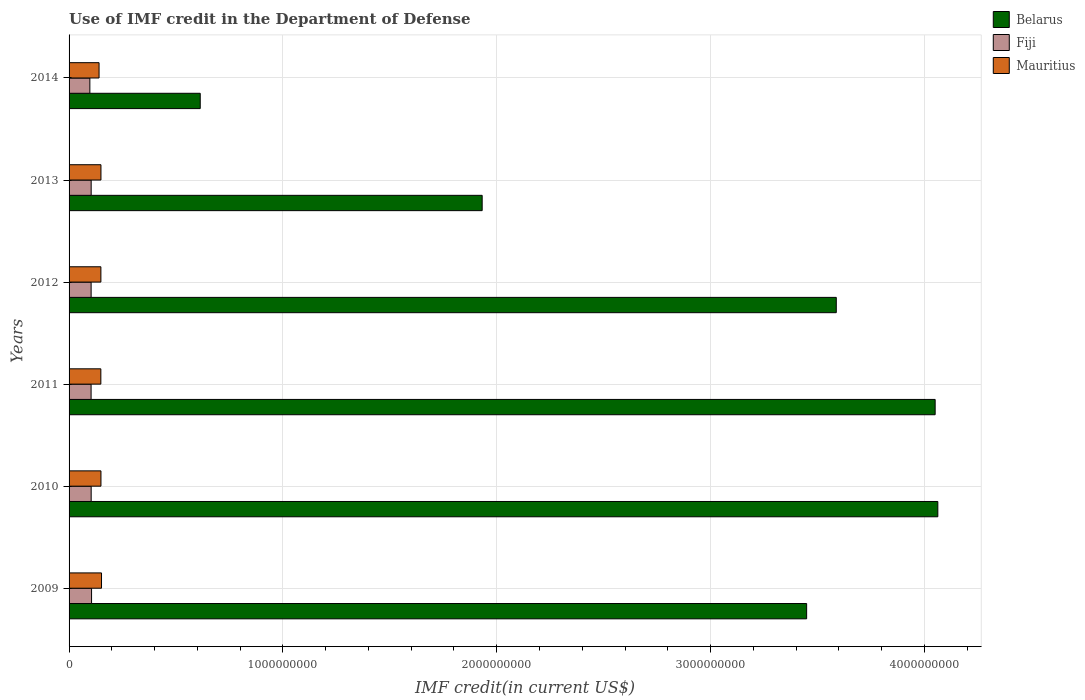How many different coloured bars are there?
Keep it short and to the point. 3. Are the number of bars per tick equal to the number of legend labels?
Your answer should be compact. Yes. How many bars are there on the 1st tick from the top?
Offer a terse response. 3. How many bars are there on the 5th tick from the bottom?
Provide a short and direct response. 3. What is the label of the 3rd group of bars from the top?
Offer a very short reply. 2012. What is the IMF credit in the Department of Defense in Fiji in 2013?
Your answer should be very brief. 1.03e+08. Across all years, what is the maximum IMF credit in the Department of Defense in Fiji?
Offer a terse response. 1.05e+08. Across all years, what is the minimum IMF credit in the Department of Defense in Belarus?
Make the answer very short. 6.13e+08. In which year was the IMF credit in the Department of Defense in Mauritius minimum?
Offer a terse response. 2014. What is the total IMF credit in the Department of Defense in Fiji in the graph?
Make the answer very short. 6.15e+08. What is the difference between the IMF credit in the Department of Defense in Fiji in 2011 and that in 2012?
Ensure brevity in your answer.  -1.11e+05. What is the difference between the IMF credit in the Department of Defense in Mauritius in 2009 and the IMF credit in the Department of Defense in Fiji in 2012?
Your answer should be very brief. 4.86e+07. What is the average IMF credit in the Department of Defense in Belarus per year?
Ensure brevity in your answer.  2.95e+09. In the year 2011, what is the difference between the IMF credit in the Department of Defense in Mauritius and IMF credit in the Department of Defense in Fiji?
Offer a very short reply. 4.56e+07. What is the ratio of the IMF credit in the Department of Defense in Fiji in 2011 to that in 2013?
Keep it short and to the point. 1. Is the difference between the IMF credit in the Department of Defense in Mauritius in 2012 and 2014 greater than the difference between the IMF credit in the Department of Defense in Fiji in 2012 and 2014?
Provide a short and direct response. Yes. What is the difference between the highest and the second highest IMF credit in the Department of Defense in Mauritius?
Offer a very short reply. 2.68e+06. What is the difference between the highest and the lowest IMF credit in the Department of Defense in Belarus?
Provide a succinct answer. 3.45e+09. In how many years, is the IMF credit in the Department of Defense in Fiji greater than the average IMF credit in the Department of Defense in Fiji taken over all years?
Keep it short and to the point. 5. Is the sum of the IMF credit in the Department of Defense in Mauritius in 2009 and 2010 greater than the maximum IMF credit in the Department of Defense in Belarus across all years?
Provide a short and direct response. No. What does the 2nd bar from the top in 2012 represents?
Provide a succinct answer. Fiji. What does the 3rd bar from the bottom in 2012 represents?
Make the answer very short. Mauritius. How many bars are there?
Provide a short and direct response. 18. Are all the bars in the graph horizontal?
Keep it short and to the point. Yes. How many years are there in the graph?
Provide a short and direct response. 6. Where does the legend appear in the graph?
Give a very brief answer. Top right. How many legend labels are there?
Your answer should be compact. 3. How are the legend labels stacked?
Provide a short and direct response. Vertical. What is the title of the graph?
Provide a succinct answer. Use of IMF credit in the Department of Defense. What is the label or title of the X-axis?
Your response must be concise. IMF credit(in current US$). What is the label or title of the Y-axis?
Make the answer very short. Years. What is the IMF credit(in current US$) of Belarus in 2009?
Provide a succinct answer. 3.45e+09. What is the IMF credit(in current US$) of Fiji in 2009?
Offer a terse response. 1.05e+08. What is the IMF credit(in current US$) in Mauritius in 2009?
Keep it short and to the point. 1.52e+08. What is the IMF credit(in current US$) in Belarus in 2010?
Your response must be concise. 4.06e+09. What is the IMF credit(in current US$) of Fiji in 2010?
Your answer should be very brief. 1.03e+08. What is the IMF credit(in current US$) of Mauritius in 2010?
Offer a very short reply. 1.49e+08. What is the IMF credit(in current US$) in Belarus in 2011?
Offer a very short reply. 4.05e+09. What is the IMF credit(in current US$) of Fiji in 2011?
Offer a very short reply. 1.03e+08. What is the IMF credit(in current US$) in Mauritius in 2011?
Your answer should be very brief. 1.49e+08. What is the IMF credit(in current US$) in Belarus in 2012?
Provide a succinct answer. 3.59e+09. What is the IMF credit(in current US$) of Fiji in 2012?
Offer a very short reply. 1.03e+08. What is the IMF credit(in current US$) of Mauritius in 2012?
Your answer should be compact. 1.49e+08. What is the IMF credit(in current US$) of Belarus in 2013?
Keep it short and to the point. 1.93e+09. What is the IMF credit(in current US$) of Fiji in 2013?
Your answer should be compact. 1.03e+08. What is the IMF credit(in current US$) in Mauritius in 2013?
Ensure brevity in your answer.  1.49e+08. What is the IMF credit(in current US$) in Belarus in 2014?
Make the answer very short. 6.13e+08. What is the IMF credit(in current US$) of Fiji in 2014?
Offer a terse response. 9.72e+07. What is the IMF credit(in current US$) of Mauritius in 2014?
Offer a very short reply. 1.40e+08. Across all years, what is the maximum IMF credit(in current US$) in Belarus?
Offer a very short reply. 4.06e+09. Across all years, what is the maximum IMF credit(in current US$) in Fiji?
Provide a short and direct response. 1.05e+08. Across all years, what is the maximum IMF credit(in current US$) of Mauritius?
Offer a terse response. 1.52e+08. Across all years, what is the minimum IMF credit(in current US$) of Belarus?
Offer a terse response. 6.13e+08. Across all years, what is the minimum IMF credit(in current US$) in Fiji?
Ensure brevity in your answer.  9.72e+07. Across all years, what is the minimum IMF credit(in current US$) in Mauritius?
Make the answer very short. 1.40e+08. What is the total IMF credit(in current US$) in Belarus in the graph?
Keep it short and to the point. 1.77e+1. What is the total IMF credit(in current US$) in Fiji in the graph?
Provide a succinct answer. 6.15e+08. What is the total IMF credit(in current US$) of Mauritius in the graph?
Keep it short and to the point. 8.88e+08. What is the difference between the IMF credit(in current US$) in Belarus in 2009 and that in 2010?
Your answer should be compact. -6.14e+08. What is the difference between the IMF credit(in current US$) in Fiji in 2009 and that in 2010?
Give a very brief answer. 1.86e+06. What is the difference between the IMF credit(in current US$) of Mauritius in 2009 and that in 2010?
Provide a succinct answer. 2.68e+06. What is the difference between the IMF credit(in current US$) in Belarus in 2009 and that in 2011?
Provide a succinct answer. -6.01e+08. What is the difference between the IMF credit(in current US$) in Fiji in 2009 and that in 2011?
Make the answer very short. 2.18e+06. What is the difference between the IMF credit(in current US$) of Mauritius in 2009 and that in 2011?
Provide a succinct answer. 3.14e+06. What is the difference between the IMF credit(in current US$) in Belarus in 2009 and that in 2012?
Provide a short and direct response. -1.39e+08. What is the difference between the IMF credit(in current US$) of Fiji in 2009 and that in 2012?
Provide a succinct answer. 2.06e+06. What is the difference between the IMF credit(in current US$) in Mauritius in 2009 and that in 2012?
Provide a short and direct response. 2.98e+06. What is the difference between the IMF credit(in current US$) in Belarus in 2009 and that in 2013?
Provide a succinct answer. 1.52e+09. What is the difference between the IMF credit(in current US$) of Fiji in 2009 and that in 2013?
Provide a short and direct response. 1.86e+06. What is the difference between the IMF credit(in current US$) in Mauritius in 2009 and that in 2013?
Make the answer very short. 2.68e+06. What is the difference between the IMF credit(in current US$) in Belarus in 2009 and that in 2014?
Provide a short and direct response. 2.84e+09. What is the difference between the IMF credit(in current US$) of Fiji in 2009 and that in 2014?
Your answer should be compact. 7.98e+06. What is the difference between the IMF credit(in current US$) of Mauritius in 2009 and that in 2014?
Ensure brevity in your answer.  1.15e+07. What is the difference between the IMF credit(in current US$) in Belarus in 2010 and that in 2011?
Provide a short and direct response. 1.26e+07. What is the difference between the IMF credit(in current US$) of Fiji in 2010 and that in 2011?
Your response must be concise. 3.19e+05. What is the difference between the IMF credit(in current US$) of Mauritius in 2010 and that in 2011?
Your answer should be very brief. 4.60e+05. What is the difference between the IMF credit(in current US$) of Belarus in 2010 and that in 2012?
Make the answer very short. 4.75e+08. What is the difference between the IMF credit(in current US$) in Fiji in 2010 and that in 2012?
Your response must be concise. 2.08e+05. What is the difference between the IMF credit(in current US$) of Mauritius in 2010 and that in 2012?
Keep it short and to the point. 3.01e+05. What is the difference between the IMF credit(in current US$) in Belarus in 2010 and that in 2013?
Provide a short and direct response. 2.13e+09. What is the difference between the IMF credit(in current US$) of Belarus in 2010 and that in 2014?
Your answer should be very brief. 3.45e+09. What is the difference between the IMF credit(in current US$) in Fiji in 2010 and that in 2014?
Provide a succinct answer. 6.12e+06. What is the difference between the IMF credit(in current US$) in Mauritius in 2010 and that in 2014?
Provide a short and direct response. 8.83e+06. What is the difference between the IMF credit(in current US$) in Belarus in 2011 and that in 2012?
Your answer should be compact. 4.62e+08. What is the difference between the IMF credit(in current US$) of Fiji in 2011 and that in 2012?
Give a very brief answer. -1.11e+05. What is the difference between the IMF credit(in current US$) of Mauritius in 2011 and that in 2012?
Provide a short and direct response. -1.59e+05. What is the difference between the IMF credit(in current US$) in Belarus in 2011 and that in 2013?
Give a very brief answer. 2.12e+09. What is the difference between the IMF credit(in current US$) in Fiji in 2011 and that in 2013?
Your response must be concise. -3.17e+05. What is the difference between the IMF credit(in current US$) of Mauritius in 2011 and that in 2013?
Your response must be concise. -4.58e+05. What is the difference between the IMF credit(in current US$) in Belarus in 2011 and that in 2014?
Provide a succinct answer. 3.44e+09. What is the difference between the IMF credit(in current US$) of Fiji in 2011 and that in 2014?
Your response must be concise. 5.80e+06. What is the difference between the IMF credit(in current US$) in Mauritius in 2011 and that in 2014?
Keep it short and to the point. 8.37e+06. What is the difference between the IMF credit(in current US$) in Belarus in 2012 and that in 2013?
Your response must be concise. 1.66e+09. What is the difference between the IMF credit(in current US$) of Fiji in 2012 and that in 2013?
Your answer should be compact. -2.06e+05. What is the difference between the IMF credit(in current US$) of Mauritius in 2012 and that in 2013?
Provide a succinct answer. -2.99e+05. What is the difference between the IMF credit(in current US$) of Belarus in 2012 and that in 2014?
Your answer should be very brief. 2.97e+09. What is the difference between the IMF credit(in current US$) in Fiji in 2012 and that in 2014?
Your answer should be very brief. 5.91e+06. What is the difference between the IMF credit(in current US$) of Mauritius in 2012 and that in 2014?
Give a very brief answer. 8.53e+06. What is the difference between the IMF credit(in current US$) of Belarus in 2013 and that in 2014?
Your answer should be compact. 1.32e+09. What is the difference between the IMF credit(in current US$) of Fiji in 2013 and that in 2014?
Give a very brief answer. 6.12e+06. What is the difference between the IMF credit(in current US$) of Mauritius in 2013 and that in 2014?
Your answer should be compact. 8.83e+06. What is the difference between the IMF credit(in current US$) of Belarus in 2009 and the IMF credit(in current US$) of Fiji in 2010?
Provide a succinct answer. 3.35e+09. What is the difference between the IMF credit(in current US$) of Belarus in 2009 and the IMF credit(in current US$) of Mauritius in 2010?
Give a very brief answer. 3.30e+09. What is the difference between the IMF credit(in current US$) in Fiji in 2009 and the IMF credit(in current US$) in Mauritius in 2010?
Offer a terse response. -4.39e+07. What is the difference between the IMF credit(in current US$) in Belarus in 2009 and the IMF credit(in current US$) in Fiji in 2011?
Your answer should be very brief. 3.35e+09. What is the difference between the IMF credit(in current US$) in Belarus in 2009 and the IMF credit(in current US$) in Mauritius in 2011?
Your answer should be very brief. 3.30e+09. What is the difference between the IMF credit(in current US$) in Fiji in 2009 and the IMF credit(in current US$) in Mauritius in 2011?
Your response must be concise. -4.34e+07. What is the difference between the IMF credit(in current US$) in Belarus in 2009 and the IMF credit(in current US$) in Fiji in 2012?
Provide a succinct answer. 3.35e+09. What is the difference between the IMF credit(in current US$) in Belarus in 2009 and the IMF credit(in current US$) in Mauritius in 2012?
Ensure brevity in your answer.  3.30e+09. What is the difference between the IMF credit(in current US$) of Fiji in 2009 and the IMF credit(in current US$) of Mauritius in 2012?
Provide a succinct answer. -4.36e+07. What is the difference between the IMF credit(in current US$) of Belarus in 2009 and the IMF credit(in current US$) of Fiji in 2013?
Your response must be concise. 3.35e+09. What is the difference between the IMF credit(in current US$) in Belarus in 2009 and the IMF credit(in current US$) in Mauritius in 2013?
Offer a terse response. 3.30e+09. What is the difference between the IMF credit(in current US$) of Fiji in 2009 and the IMF credit(in current US$) of Mauritius in 2013?
Keep it short and to the point. -4.39e+07. What is the difference between the IMF credit(in current US$) of Belarus in 2009 and the IMF credit(in current US$) of Fiji in 2014?
Offer a very short reply. 3.35e+09. What is the difference between the IMF credit(in current US$) of Belarus in 2009 and the IMF credit(in current US$) of Mauritius in 2014?
Ensure brevity in your answer.  3.31e+09. What is the difference between the IMF credit(in current US$) in Fiji in 2009 and the IMF credit(in current US$) in Mauritius in 2014?
Ensure brevity in your answer.  -3.51e+07. What is the difference between the IMF credit(in current US$) in Belarus in 2010 and the IMF credit(in current US$) in Fiji in 2011?
Give a very brief answer. 3.96e+09. What is the difference between the IMF credit(in current US$) of Belarus in 2010 and the IMF credit(in current US$) of Mauritius in 2011?
Keep it short and to the point. 3.91e+09. What is the difference between the IMF credit(in current US$) of Fiji in 2010 and the IMF credit(in current US$) of Mauritius in 2011?
Your answer should be compact. -4.53e+07. What is the difference between the IMF credit(in current US$) in Belarus in 2010 and the IMF credit(in current US$) in Fiji in 2012?
Provide a succinct answer. 3.96e+09. What is the difference between the IMF credit(in current US$) in Belarus in 2010 and the IMF credit(in current US$) in Mauritius in 2012?
Your response must be concise. 3.91e+09. What is the difference between the IMF credit(in current US$) of Fiji in 2010 and the IMF credit(in current US$) of Mauritius in 2012?
Provide a succinct answer. -4.55e+07. What is the difference between the IMF credit(in current US$) in Belarus in 2010 and the IMF credit(in current US$) in Fiji in 2013?
Provide a succinct answer. 3.96e+09. What is the difference between the IMF credit(in current US$) of Belarus in 2010 and the IMF credit(in current US$) of Mauritius in 2013?
Ensure brevity in your answer.  3.91e+09. What is the difference between the IMF credit(in current US$) in Fiji in 2010 and the IMF credit(in current US$) in Mauritius in 2013?
Provide a short and direct response. -4.58e+07. What is the difference between the IMF credit(in current US$) of Belarus in 2010 and the IMF credit(in current US$) of Fiji in 2014?
Your answer should be compact. 3.97e+09. What is the difference between the IMF credit(in current US$) in Belarus in 2010 and the IMF credit(in current US$) in Mauritius in 2014?
Keep it short and to the point. 3.92e+09. What is the difference between the IMF credit(in current US$) in Fiji in 2010 and the IMF credit(in current US$) in Mauritius in 2014?
Offer a very short reply. -3.69e+07. What is the difference between the IMF credit(in current US$) in Belarus in 2011 and the IMF credit(in current US$) in Fiji in 2012?
Your answer should be very brief. 3.95e+09. What is the difference between the IMF credit(in current US$) in Belarus in 2011 and the IMF credit(in current US$) in Mauritius in 2012?
Make the answer very short. 3.90e+09. What is the difference between the IMF credit(in current US$) in Fiji in 2011 and the IMF credit(in current US$) in Mauritius in 2012?
Make the answer very short. -4.58e+07. What is the difference between the IMF credit(in current US$) of Belarus in 2011 and the IMF credit(in current US$) of Fiji in 2013?
Offer a terse response. 3.95e+09. What is the difference between the IMF credit(in current US$) in Belarus in 2011 and the IMF credit(in current US$) in Mauritius in 2013?
Offer a very short reply. 3.90e+09. What is the difference between the IMF credit(in current US$) of Fiji in 2011 and the IMF credit(in current US$) of Mauritius in 2013?
Your answer should be very brief. -4.61e+07. What is the difference between the IMF credit(in current US$) of Belarus in 2011 and the IMF credit(in current US$) of Fiji in 2014?
Provide a succinct answer. 3.95e+09. What is the difference between the IMF credit(in current US$) in Belarus in 2011 and the IMF credit(in current US$) in Mauritius in 2014?
Keep it short and to the point. 3.91e+09. What is the difference between the IMF credit(in current US$) of Fiji in 2011 and the IMF credit(in current US$) of Mauritius in 2014?
Offer a very short reply. -3.72e+07. What is the difference between the IMF credit(in current US$) in Belarus in 2012 and the IMF credit(in current US$) in Fiji in 2013?
Make the answer very short. 3.48e+09. What is the difference between the IMF credit(in current US$) of Belarus in 2012 and the IMF credit(in current US$) of Mauritius in 2013?
Give a very brief answer. 3.44e+09. What is the difference between the IMF credit(in current US$) in Fiji in 2012 and the IMF credit(in current US$) in Mauritius in 2013?
Your answer should be very brief. -4.60e+07. What is the difference between the IMF credit(in current US$) in Belarus in 2012 and the IMF credit(in current US$) in Fiji in 2014?
Your response must be concise. 3.49e+09. What is the difference between the IMF credit(in current US$) of Belarus in 2012 and the IMF credit(in current US$) of Mauritius in 2014?
Your answer should be very brief. 3.45e+09. What is the difference between the IMF credit(in current US$) of Fiji in 2012 and the IMF credit(in current US$) of Mauritius in 2014?
Keep it short and to the point. -3.71e+07. What is the difference between the IMF credit(in current US$) in Belarus in 2013 and the IMF credit(in current US$) in Fiji in 2014?
Keep it short and to the point. 1.83e+09. What is the difference between the IMF credit(in current US$) in Belarus in 2013 and the IMF credit(in current US$) in Mauritius in 2014?
Provide a short and direct response. 1.79e+09. What is the difference between the IMF credit(in current US$) of Fiji in 2013 and the IMF credit(in current US$) of Mauritius in 2014?
Your response must be concise. -3.69e+07. What is the average IMF credit(in current US$) of Belarus per year?
Provide a succinct answer. 2.95e+09. What is the average IMF credit(in current US$) in Fiji per year?
Your answer should be compact. 1.03e+08. What is the average IMF credit(in current US$) of Mauritius per year?
Provide a succinct answer. 1.48e+08. In the year 2009, what is the difference between the IMF credit(in current US$) of Belarus and IMF credit(in current US$) of Fiji?
Provide a short and direct response. 3.34e+09. In the year 2009, what is the difference between the IMF credit(in current US$) of Belarus and IMF credit(in current US$) of Mauritius?
Offer a terse response. 3.30e+09. In the year 2009, what is the difference between the IMF credit(in current US$) of Fiji and IMF credit(in current US$) of Mauritius?
Provide a short and direct response. -4.66e+07. In the year 2010, what is the difference between the IMF credit(in current US$) in Belarus and IMF credit(in current US$) in Fiji?
Your response must be concise. 3.96e+09. In the year 2010, what is the difference between the IMF credit(in current US$) in Belarus and IMF credit(in current US$) in Mauritius?
Give a very brief answer. 3.91e+09. In the year 2010, what is the difference between the IMF credit(in current US$) in Fiji and IMF credit(in current US$) in Mauritius?
Your response must be concise. -4.58e+07. In the year 2011, what is the difference between the IMF credit(in current US$) of Belarus and IMF credit(in current US$) of Fiji?
Your response must be concise. 3.95e+09. In the year 2011, what is the difference between the IMF credit(in current US$) in Belarus and IMF credit(in current US$) in Mauritius?
Give a very brief answer. 3.90e+09. In the year 2011, what is the difference between the IMF credit(in current US$) in Fiji and IMF credit(in current US$) in Mauritius?
Ensure brevity in your answer.  -4.56e+07. In the year 2012, what is the difference between the IMF credit(in current US$) in Belarus and IMF credit(in current US$) in Fiji?
Provide a short and direct response. 3.48e+09. In the year 2012, what is the difference between the IMF credit(in current US$) in Belarus and IMF credit(in current US$) in Mauritius?
Offer a terse response. 3.44e+09. In the year 2012, what is the difference between the IMF credit(in current US$) in Fiji and IMF credit(in current US$) in Mauritius?
Give a very brief answer. -4.57e+07. In the year 2013, what is the difference between the IMF credit(in current US$) in Belarus and IMF credit(in current US$) in Fiji?
Offer a very short reply. 1.83e+09. In the year 2013, what is the difference between the IMF credit(in current US$) of Belarus and IMF credit(in current US$) of Mauritius?
Your answer should be compact. 1.78e+09. In the year 2013, what is the difference between the IMF credit(in current US$) of Fiji and IMF credit(in current US$) of Mauritius?
Provide a short and direct response. -4.58e+07. In the year 2014, what is the difference between the IMF credit(in current US$) of Belarus and IMF credit(in current US$) of Fiji?
Give a very brief answer. 5.16e+08. In the year 2014, what is the difference between the IMF credit(in current US$) in Belarus and IMF credit(in current US$) in Mauritius?
Provide a succinct answer. 4.73e+08. In the year 2014, what is the difference between the IMF credit(in current US$) of Fiji and IMF credit(in current US$) of Mauritius?
Your response must be concise. -4.30e+07. What is the ratio of the IMF credit(in current US$) in Belarus in 2009 to that in 2010?
Your response must be concise. 0.85. What is the ratio of the IMF credit(in current US$) in Fiji in 2009 to that in 2010?
Your answer should be very brief. 1.02. What is the ratio of the IMF credit(in current US$) of Mauritius in 2009 to that in 2010?
Ensure brevity in your answer.  1.02. What is the ratio of the IMF credit(in current US$) of Belarus in 2009 to that in 2011?
Make the answer very short. 0.85. What is the ratio of the IMF credit(in current US$) in Fiji in 2009 to that in 2011?
Your response must be concise. 1.02. What is the ratio of the IMF credit(in current US$) of Mauritius in 2009 to that in 2011?
Offer a terse response. 1.02. What is the ratio of the IMF credit(in current US$) in Belarus in 2009 to that in 2012?
Your answer should be compact. 0.96. What is the ratio of the IMF credit(in current US$) of Mauritius in 2009 to that in 2012?
Offer a terse response. 1.02. What is the ratio of the IMF credit(in current US$) of Belarus in 2009 to that in 2013?
Make the answer very short. 1.79. What is the ratio of the IMF credit(in current US$) in Belarus in 2009 to that in 2014?
Give a very brief answer. 5.62. What is the ratio of the IMF credit(in current US$) of Fiji in 2009 to that in 2014?
Offer a terse response. 1.08. What is the ratio of the IMF credit(in current US$) of Mauritius in 2009 to that in 2014?
Provide a succinct answer. 1.08. What is the ratio of the IMF credit(in current US$) of Belarus in 2010 to that in 2012?
Make the answer very short. 1.13. What is the ratio of the IMF credit(in current US$) in Fiji in 2010 to that in 2012?
Provide a short and direct response. 1. What is the ratio of the IMF credit(in current US$) in Belarus in 2010 to that in 2013?
Your answer should be very brief. 2.1. What is the ratio of the IMF credit(in current US$) in Belarus in 2010 to that in 2014?
Your answer should be very brief. 6.62. What is the ratio of the IMF credit(in current US$) in Fiji in 2010 to that in 2014?
Your response must be concise. 1.06. What is the ratio of the IMF credit(in current US$) in Mauritius in 2010 to that in 2014?
Your answer should be compact. 1.06. What is the ratio of the IMF credit(in current US$) in Belarus in 2011 to that in 2012?
Offer a terse response. 1.13. What is the ratio of the IMF credit(in current US$) of Belarus in 2011 to that in 2013?
Give a very brief answer. 2.1. What is the ratio of the IMF credit(in current US$) of Belarus in 2011 to that in 2014?
Keep it short and to the point. 6.6. What is the ratio of the IMF credit(in current US$) in Fiji in 2011 to that in 2014?
Provide a short and direct response. 1.06. What is the ratio of the IMF credit(in current US$) of Mauritius in 2011 to that in 2014?
Offer a terse response. 1.06. What is the ratio of the IMF credit(in current US$) in Belarus in 2012 to that in 2013?
Provide a succinct answer. 1.86. What is the ratio of the IMF credit(in current US$) in Belarus in 2012 to that in 2014?
Provide a succinct answer. 5.85. What is the ratio of the IMF credit(in current US$) of Fiji in 2012 to that in 2014?
Provide a short and direct response. 1.06. What is the ratio of the IMF credit(in current US$) in Mauritius in 2012 to that in 2014?
Your response must be concise. 1.06. What is the ratio of the IMF credit(in current US$) in Belarus in 2013 to that in 2014?
Ensure brevity in your answer.  3.15. What is the ratio of the IMF credit(in current US$) of Fiji in 2013 to that in 2014?
Provide a short and direct response. 1.06. What is the ratio of the IMF credit(in current US$) of Mauritius in 2013 to that in 2014?
Provide a succinct answer. 1.06. What is the difference between the highest and the second highest IMF credit(in current US$) in Belarus?
Make the answer very short. 1.26e+07. What is the difference between the highest and the second highest IMF credit(in current US$) of Fiji?
Offer a very short reply. 1.86e+06. What is the difference between the highest and the second highest IMF credit(in current US$) of Mauritius?
Your response must be concise. 2.68e+06. What is the difference between the highest and the lowest IMF credit(in current US$) in Belarus?
Make the answer very short. 3.45e+09. What is the difference between the highest and the lowest IMF credit(in current US$) of Fiji?
Ensure brevity in your answer.  7.98e+06. What is the difference between the highest and the lowest IMF credit(in current US$) of Mauritius?
Offer a very short reply. 1.15e+07. 